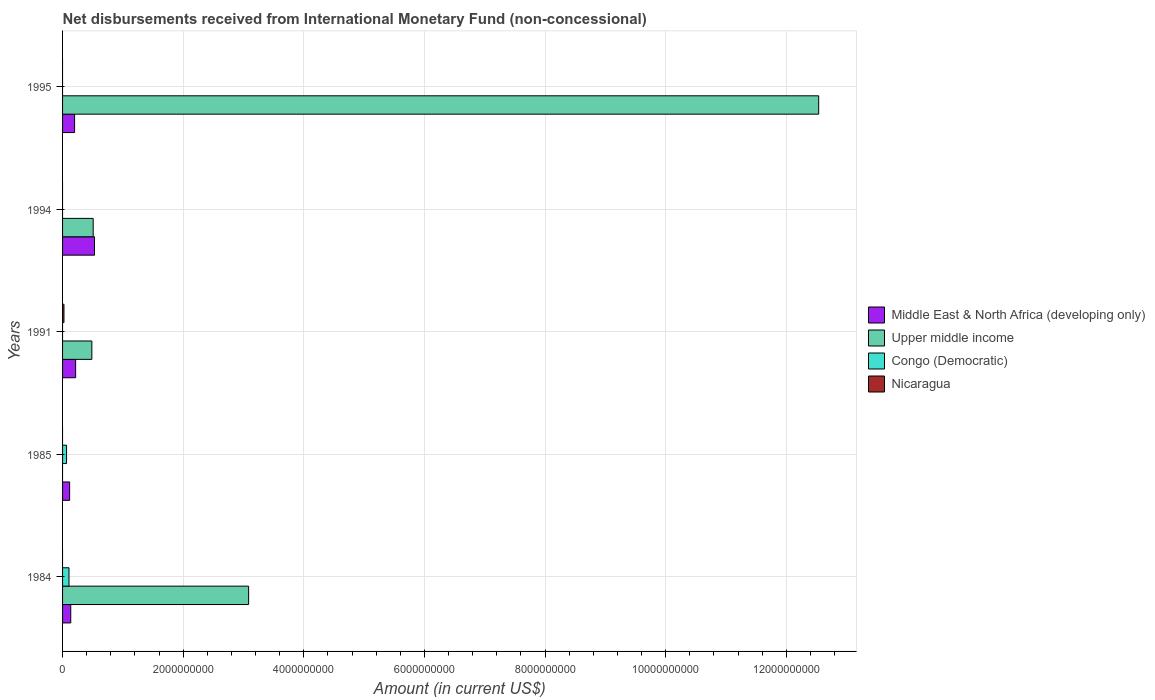How many bars are there on the 4th tick from the top?
Offer a very short reply. 2. How many bars are there on the 1st tick from the bottom?
Offer a terse response. 3. What is the label of the 1st group of bars from the top?
Offer a very short reply. 1995. What is the amount of disbursements received from International Monetary Fund in Upper middle income in 1994?
Provide a succinct answer. 5.08e+08. Across all years, what is the maximum amount of disbursements received from International Monetary Fund in Nicaragua?
Offer a very short reply. 2.33e+07. Across all years, what is the minimum amount of disbursements received from International Monetary Fund in Nicaragua?
Ensure brevity in your answer.  0. What is the total amount of disbursements received from International Monetary Fund in Congo (Democratic) in the graph?
Provide a succinct answer. 1.73e+08. What is the difference between the amount of disbursements received from International Monetary Fund in Congo (Democratic) in 1984 and that in 1985?
Make the answer very short. 4.04e+07. What is the difference between the amount of disbursements received from International Monetary Fund in Middle East & North Africa (developing only) in 1991 and the amount of disbursements received from International Monetary Fund in Nicaragua in 1995?
Give a very brief answer. 2.17e+08. What is the average amount of disbursements received from International Monetary Fund in Upper middle income per year?
Your answer should be very brief. 3.32e+09. In the year 1991, what is the difference between the amount of disbursements received from International Monetary Fund in Nicaragua and amount of disbursements received from International Monetary Fund in Middle East & North Africa (developing only)?
Make the answer very short. -1.93e+08. In how many years, is the amount of disbursements received from International Monetary Fund in Nicaragua greater than 8400000000 US$?
Provide a short and direct response. 0. What is the ratio of the amount of disbursements received from International Monetary Fund in Upper middle income in 1991 to that in 1995?
Your response must be concise. 0.04. What is the difference between the highest and the second highest amount of disbursements received from International Monetary Fund in Upper middle income?
Offer a very short reply. 9.45e+09. What is the difference between the highest and the lowest amount of disbursements received from International Monetary Fund in Middle East & North Africa (developing only)?
Your answer should be compact. 4.12e+08. Is the sum of the amount of disbursements received from International Monetary Fund in Middle East & North Africa (developing only) in 1985 and 1995 greater than the maximum amount of disbursements received from International Monetary Fund in Congo (Democratic) across all years?
Provide a succinct answer. Yes. Is it the case that in every year, the sum of the amount of disbursements received from International Monetary Fund in Middle East & North Africa (developing only) and amount of disbursements received from International Monetary Fund in Congo (Democratic) is greater than the sum of amount of disbursements received from International Monetary Fund in Nicaragua and amount of disbursements received from International Monetary Fund in Upper middle income?
Ensure brevity in your answer.  No. Is it the case that in every year, the sum of the amount of disbursements received from International Monetary Fund in Nicaragua and amount of disbursements received from International Monetary Fund in Middle East & North Africa (developing only) is greater than the amount of disbursements received from International Monetary Fund in Upper middle income?
Provide a short and direct response. No. How many bars are there?
Your answer should be compact. 12. Are all the bars in the graph horizontal?
Provide a succinct answer. Yes. How many years are there in the graph?
Ensure brevity in your answer.  5. What is the difference between two consecutive major ticks on the X-axis?
Keep it short and to the point. 2.00e+09. Are the values on the major ticks of X-axis written in scientific E-notation?
Your answer should be very brief. No. Does the graph contain any zero values?
Offer a very short reply. Yes. Where does the legend appear in the graph?
Your answer should be compact. Center right. What is the title of the graph?
Offer a terse response. Net disbursements received from International Monetary Fund (non-concessional). Does "Cameroon" appear as one of the legend labels in the graph?
Provide a succinct answer. No. What is the label or title of the X-axis?
Make the answer very short. Amount (in current US$). What is the Amount (in current US$) of Middle East & North Africa (developing only) in 1984?
Your response must be concise. 1.36e+08. What is the Amount (in current US$) in Upper middle income in 1984?
Provide a short and direct response. 3.08e+09. What is the Amount (in current US$) in Congo (Democratic) in 1984?
Keep it short and to the point. 1.07e+08. What is the Amount (in current US$) in Middle East & North Africa (developing only) in 1985?
Provide a succinct answer. 1.17e+08. What is the Amount (in current US$) in Congo (Democratic) in 1985?
Give a very brief answer. 6.62e+07. What is the Amount (in current US$) in Nicaragua in 1985?
Make the answer very short. 0. What is the Amount (in current US$) of Middle East & North Africa (developing only) in 1991?
Keep it short and to the point. 2.17e+08. What is the Amount (in current US$) of Upper middle income in 1991?
Provide a succinct answer. 4.86e+08. What is the Amount (in current US$) in Nicaragua in 1991?
Your answer should be very brief. 2.33e+07. What is the Amount (in current US$) in Middle East & North Africa (developing only) in 1994?
Offer a very short reply. 5.29e+08. What is the Amount (in current US$) of Upper middle income in 1994?
Provide a short and direct response. 5.08e+08. What is the Amount (in current US$) of Nicaragua in 1994?
Provide a succinct answer. 0. What is the Amount (in current US$) in Middle East & North Africa (developing only) in 1995?
Provide a short and direct response. 1.99e+08. What is the Amount (in current US$) in Upper middle income in 1995?
Provide a short and direct response. 1.25e+1. What is the Amount (in current US$) in Congo (Democratic) in 1995?
Your answer should be compact. 0. What is the Amount (in current US$) in Nicaragua in 1995?
Your answer should be compact. 0. Across all years, what is the maximum Amount (in current US$) in Middle East & North Africa (developing only)?
Provide a succinct answer. 5.29e+08. Across all years, what is the maximum Amount (in current US$) in Upper middle income?
Make the answer very short. 1.25e+1. Across all years, what is the maximum Amount (in current US$) of Congo (Democratic)?
Your answer should be very brief. 1.07e+08. Across all years, what is the maximum Amount (in current US$) of Nicaragua?
Ensure brevity in your answer.  2.33e+07. Across all years, what is the minimum Amount (in current US$) in Middle East & North Africa (developing only)?
Keep it short and to the point. 1.17e+08. Across all years, what is the minimum Amount (in current US$) of Upper middle income?
Ensure brevity in your answer.  0. Across all years, what is the minimum Amount (in current US$) of Congo (Democratic)?
Ensure brevity in your answer.  0. What is the total Amount (in current US$) in Middle East & North Africa (developing only) in the graph?
Make the answer very short. 1.20e+09. What is the total Amount (in current US$) in Upper middle income in the graph?
Your response must be concise. 1.66e+1. What is the total Amount (in current US$) of Congo (Democratic) in the graph?
Make the answer very short. 1.73e+08. What is the total Amount (in current US$) of Nicaragua in the graph?
Keep it short and to the point. 2.33e+07. What is the difference between the Amount (in current US$) of Middle East & North Africa (developing only) in 1984 and that in 1985?
Make the answer very short. 1.84e+07. What is the difference between the Amount (in current US$) of Congo (Democratic) in 1984 and that in 1985?
Offer a very short reply. 4.04e+07. What is the difference between the Amount (in current US$) in Middle East & North Africa (developing only) in 1984 and that in 1991?
Keep it short and to the point. -8.10e+07. What is the difference between the Amount (in current US$) of Upper middle income in 1984 and that in 1991?
Your response must be concise. 2.60e+09. What is the difference between the Amount (in current US$) in Middle East & North Africa (developing only) in 1984 and that in 1994?
Offer a very short reply. -3.94e+08. What is the difference between the Amount (in current US$) of Upper middle income in 1984 and that in 1994?
Provide a short and direct response. 2.58e+09. What is the difference between the Amount (in current US$) of Middle East & North Africa (developing only) in 1984 and that in 1995?
Your response must be concise. -6.36e+07. What is the difference between the Amount (in current US$) of Upper middle income in 1984 and that in 1995?
Ensure brevity in your answer.  -9.45e+09. What is the difference between the Amount (in current US$) of Middle East & North Africa (developing only) in 1985 and that in 1991?
Provide a succinct answer. -9.94e+07. What is the difference between the Amount (in current US$) of Middle East & North Africa (developing only) in 1985 and that in 1994?
Ensure brevity in your answer.  -4.12e+08. What is the difference between the Amount (in current US$) in Middle East & North Africa (developing only) in 1985 and that in 1995?
Your answer should be compact. -8.21e+07. What is the difference between the Amount (in current US$) in Middle East & North Africa (developing only) in 1991 and that in 1994?
Offer a terse response. -3.13e+08. What is the difference between the Amount (in current US$) in Upper middle income in 1991 and that in 1994?
Ensure brevity in your answer.  -2.20e+07. What is the difference between the Amount (in current US$) of Middle East & North Africa (developing only) in 1991 and that in 1995?
Your answer should be very brief. 1.74e+07. What is the difference between the Amount (in current US$) in Upper middle income in 1991 and that in 1995?
Keep it short and to the point. -1.21e+1. What is the difference between the Amount (in current US$) of Middle East & North Africa (developing only) in 1994 and that in 1995?
Provide a short and direct response. 3.30e+08. What is the difference between the Amount (in current US$) in Upper middle income in 1994 and that in 1995?
Give a very brief answer. -1.20e+1. What is the difference between the Amount (in current US$) in Middle East & North Africa (developing only) in 1984 and the Amount (in current US$) in Congo (Democratic) in 1985?
Provide a succinct answer. 6.96e+07. What is the difference between the Amount (in current US$) of Upper middle income in 1984 and the Amount (in current US$) of Congo (Democratic) in 1985?
Your answer should be compact. 3.02e+09. What is the difference between the Amount (in current US$) of Middle East & North Africa (developing only) in 1984 and the Amount (in current US$) of Upper middle income in 1991?
Provide a short and direct response. -3.50e+08. What is the difference between the Amount (in current US$) of Middle East & North Africa (developing only) in 1984 and the Amount (in current US$) of Nicaragua in 1991?
Your answer should be very brief. 1.12e+08. What is the difference between the Amount (in current US$) of Upper middle income in 1984 and the Amount (in current US$) of Nicaragua in 1991?
Give a very brief answer. 3.06e+09. What is the difference between the Amount (in current US$) in Congo (Democratic) in 1984 and the Amount (in current US$) in Nicaragua in 1991?
Make the answer very short. 8.33e+07. What is the difference between the Amount (in current US$) of Middle East & North Africa (developing only) in 1984 and the Amount (in current US$) of Upper middle income in 1994?
Make the answer very short. -3.72e+08. What is the difference between the Amount (in current US$) in Middle East & North Africa (developing only) in 1984 and the Amount (in current US$) in Upper middle income in 1995?
Your response must be concise. -1.24e+1. What is the difference between the Amount (in current US$) in Middle East & North Africa (developing only) in 1985 and the Amount (in current US$) in Upper middle income in 1991?
Offer a very short reply. -3.68e+08. What is the difference between the Amount (in current US$) in Middle East & North Africa (developing only) in 1985 and the Amount (in current US$) in Nicaragua in 1991?
Your answer should be very brief. 9.41e+07. What is the difference between the Amount (in current US$) of Congo (Democratic) in 1985 and the Amount (in current US$) of Nicaragua in 1991?
Your answer should be very brief. 4.29e+07. What is the difference between the Amount (in current US$) in Middle East & North Africa (developing only) in 1985 and the Amount (in current US$) in Upper middle income in 1994?
Provide a succinct answer. -3.90e+08. What is the difference between the Amount (in current US$) in Middle East & North Africa (developing only) in 1985 and the Amount (in current US$) in Upper middle income in 1995?
Make the answer very short. -1.24e+1. What is the difference between the Amount (in current US$) in Middle East & North Africa (developing only) in 1991 and the Amount (in current US$) in Upper middle income in 1994?
Offer a very short reply. -2.91e+08. What is the difference between the Amount (in current US$) of Middle East & North Africa (developing only) in 1991 and the Amount (in current US$) of Upper middle income in 1995?
Your answer should be very brief. -1.23e+1. What is the difference between the Amount (in current US$) of Middle East & North Africa (developing only) in 1994 and the Amount (in current US$) of Upper middle income in 1995?
Your answer should be compact. -1.20e+1. What is the average Amount (in current US$) of Middle East & North Africa (developing only) per year?
Offer a terse response. 2.40e+08. What is the average Amount (in current US$) in Upper middle income per year?
Offer a very short reply. 3.32e+09. What is the average Amount (in current US$) in Congo (Democratic) per year?
Your answer should be very brief. 3.46e+07. What is the average Amount (in current US$) in Nicaragua per year?
Ensure brevity in your answer.  4.66e+06. In the year 1984, what is the difference between the Amount (in current US$) of Middle East & North Africa (developing only) and Amount (in current US$) of Upper middle income?
Provide a succinct answer. -2.95e+09. In the year 1984, what is the difference between the Amount (in current US$) in Middle East & North Africa (developing only) and Amount (in current US$) in Congo (Democratic)?
Your response must be concise. 2.92e+07. In the year 1984, what is the difference between the Amount (in current US$) of Upper middle income and Amount (in current US$) of Congo (Democratic)?
Your answer should be very brief. 2.98e+09. In the year 1985, what is the difference between the Amount (in current US$) in Middle East & North Africa (developing only) and Amount (in current US$) in Congo (Democratic)?
Make the answer very short. 5.12e+07. In the year 1991, what is the difference between the Amount (in current US$) of Middle East & North Africa (developing only) and Amount (in current US$) of Upper middle income?
Your answer should be compact. -2.69e+08. In the year 1991, what is the difference between the Amount (in current US$) of Middle East & North Africa (developing only) and Amount (in current US$) of Nicaragua?
Your answer should be very brief. 1.93e+08. In the year 1991, what is the difference between the Amount (in current US$) in Upper middle income and Amount (in current US$) in Nicaragua?
Your response must be concise. 4.62e+08. In the year 1994, what is the difference between the Amount (in current US$) of Middle East & North Africa (developing only) and Amount (in current US$) of Upper middle income?
Ensure brevity in your answer.  2.17e+07. In the year 1995, what is the difference between the Amount (in current US$) of Middle East & North Africa (developing only) and Amount (in current US$) of Upper middle income?
Make the answer very short. -1.23e+1. What is the ratio of the Amount (in current US$) in Middle East & North Africa (developing only) in 1984 to that in 1985?
Provide a short and direct response. 1.16. What is the ratio of the Amount (in current US$) of Congo (Democratic) in 1984 to that in 1985?
Your answer should be compact. 1.61. What is the ratio of the Amount (in current US$) in Middle East & North Africa (developing only) in 1984 to that in 1991?
Your answer should be compact. 0.63. What is the ratio of the Amount (in current US$) of Upper middle income in 1984 to that in 1991?
Your answer should be very brief. 6.35. What is the ratio of the Amount (in current US$) in Middle East & North Africa (developing only) in 1984 to that in 1994?
Your answer should be very brief. 0.26. What is the ratio of the Amount (in current US$) of Upper middle income in 1984 to that in 1994?
Make the answer very short. 6.08. What is the ratio of the Amount (in current US$) in Middle East & North Africa (developing only) in 1984 to that in 1995?
Ensure brevity in your answer.  0.68. What is the ratio of the Amount (in current US$) in Upper middle income in 1984 to that in 1995?
Provide a succinct answer. 0.25. What is the ratio of the Amount (in current US$) in Middle East & North Africa (developing only) in 1985 to that in 1991?
Your answer should be compact. 0.54. What is the ratio of the Amount (in current US$) in Middle East & North Africa (developing only) in 1985 to that in 1994?
Keep it short and to the point. 0.22. What is the ratio of the Amount (in current US$) of Middle East & North Africa (developing only) in 1985 to that in 1995?
Provide a succinct answer. 0.59. What is the ratio of the Amount (in current US$) in Middle East & North Africa (developing only) in 1991 to that in 1994?
Your answer should be very brief. 0.41. What is the ratio of the Amount (in current US$) in Upper middle income in 1991 to that in 1994?
Give a very brief answer. 0.96. What is the ratio of the Amount (in current US$) of Middle East & North Africa (developing only) in 1991 to that in 1995?
Provide a succinct answer. 1.09. What is the ratio of the Amount (in current US$) of Upper middle income in 1991 to that in 1995?
Give a very brief answer. 0.04. What is the ratio of the Amount (in current US$) of Middle East & North Africa (developing only) in 1994 to that in 1995?
Your response must be concise. 2.65. What is the ratio of the Amount (in current US$) of Upper middle income in 1994 to that in 1995?
Provide a succinct answer. 0.04. What is the difference between the highest and the second highest Amount (in current US$) in Middle East & North Africa (developing only)?
Keep it short and to the point. 3.13e+08. What is the difference between the highest and the second highest Amount (in current US$) in Upper middle income?
Ensure brevity in your answer.  9.45e+09. What is the difference between the highest and the lowest Amount (in current US$) in Middle East & North Africa (developing only)?
Your answer should be compact. 4.12e+08. What is the difference between the highest and the lowest Amount (in current US$) of Upper middle income?
Ensure brevity in your answer.  1.25e+1. What is the difference between the highest and the lowest Amount (in current US$) in Congo (Democratic)?
Ensure brevity in your answer.  1.07e+08. What is the difference between the highest and the lowest Amount (in current US$) in Nicaragua?
Offer a very short reply. 2.33e+07. 